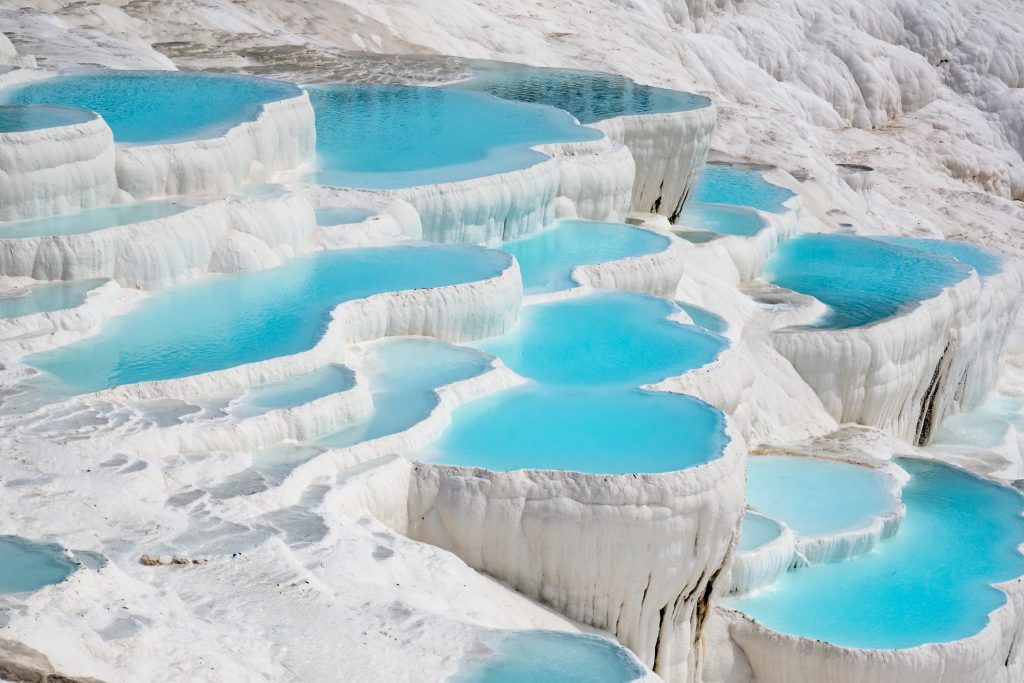Can you describe a day at Pamukkale during the busy tourist season? A day at Pamukkale during the busy tourist season is bustling with activity. Visitors from around the globe wander through the terraces, taking in the surreal landscape and snapping countless photos to capture the beauty of the cotton-like formations. Tour guides lead groups through the historical ruins of Hierapolis, weaving tales of the ancient past and the spa city’s significance. The Sacred Pool throngs with swimmers, all relishing the unique experience of bathing among ancient Roman columns. Street vendors sell local crafts and refreshments, adding a lively atmosphere to the site. Despite the crowds, the beauty of Pamukkale remains undiminished, its natural allure captivating everyone who visits. Describe a quiet day at Pamukkale. On a quiet day, Pamukkale exudes a different charm. The terraces stretch out serenely under the clear blue sky, with few visitors creating a peaceful and almost meditative atmosphere. The sound of the flowing thermal waters becomes more pronounced, adding to the tranquility. The historical ruins of Hierapolis above lie in silent grandeur, waiting for the occasional solitary traveler to wander through its ancient streets. In these moments, the beauty of Pamukkale feels even more ethereal, like stepping into a pristine paradise where time slows down, and nature’s wonders can be fully appreciated. 